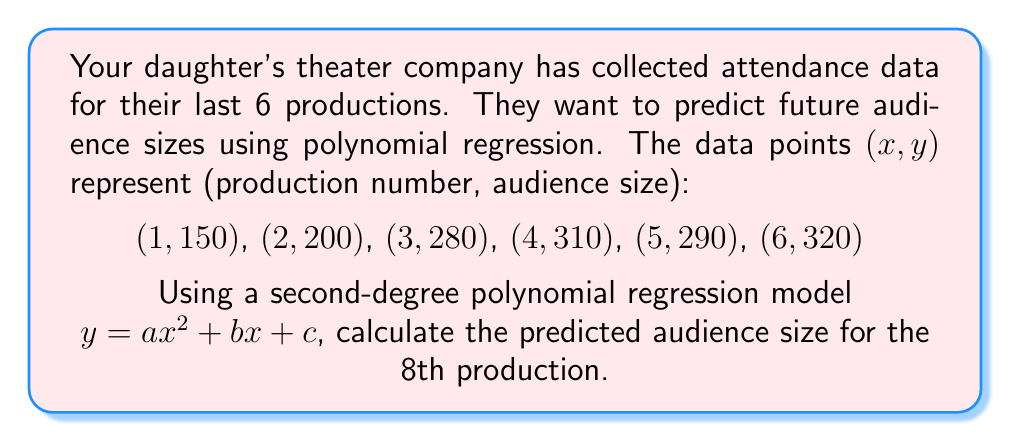Give your solution to this math problem. 1. To find the polynomial regression coefficients, we'll use the least squares method. This involves solving a system of equations:

   $$\begin{bmatrix}
   \sum x^4 & \sum x^3 & \sum x^2 \\
   \sum x^3 & \sum x^2 & \sum x \\
   \sum x^2 & \sum x & n
   \end{bmatrix}
   \begin{bmatrix}
   a \\ b \\ c
   \end{bmatrix} =
   \begin{bmatrix}
   \sum x^2y \\ \sum xy \\ \sum y
   \end{bmatrix}$$

2. Calculate the sums:
   $\sum x^4 = 1^4 + 2^4 + 3^4 + 4^4 + 5^4 + 6^4 = 979$
   $\sum x^3 = 1^3 + 2^3 + 3^3 + 4^3 + 5^3 + 6^3 = 441$
   $\sum x^2 = 1^2 + 2^2 + 3^2 + 4^2 + 5^2 + 6^2 = 91$
   $\sum x = 1 + 2 + 3 + 4 + 5 + 6 = 21$
   $n = 6$
   $\sum y = 150 + 200 + 280 + 310 + 290 + 320 = 1550$
   $\sum x^2y = 1^2(150) + 2^2(200) + 3^2(280) + 4^2(310) + 5^2(290) + 6^2(320) = 25870$
   $\sum xy = 1(150) + 2(200) + 3(280) + 4(310) + 5(290) + 6(320) = 5890$

3. Substitute into the matrix equation:

   $$\begin{bmatrix}
   979 & 441 & 91 \\
   441 & 91 & 21 \\
   91 & 21 & 6
   \end{bmatrix}
   \begin{bmatrix}
   a \\ b \\ c
   \end{bmatrix} =
   \begin{bmatrix}
   25870 \\ 5890 \\ 1550
   \end{bmatrix}$$

4. Solve this system of equations (using a calculator or computer algebra system) to get:
   $a \approx -3.7143$
   $b \approx 73.5714$
   $c \approx 76.1429$

5. The polynomial regression equation is:
   $y = -3.7143x^2 + 73.5714x + 76.1429$

6. To predict the audience size for the 8th production, substitute $x = 8$:
   $y = -3.7143(8^2) + 73.5714(8) + 76.1429$
   $y = -3.7143(64) + 73.5714(8) + 76.1429$
   $y = -237.7152 + 588.5712 + 76.1429$
   $y \approx 426.9989$

7. Round to the nearest whole number, as fractional audience members don't make sense.
Answer: 427 people 